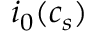<formula> <loc_0><loc_0><loc_500><loc_500>i _ { 0 } ( c _ { s } )</formula> 